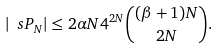<formula> <loc_0><loc_0><loc_500><loc_500>| \ s P _ { N } | \leq 2 \alpha N 4 ^ { 2 N } \binom { ( \beta + 1 ) N } { 2 N } .</formula> 